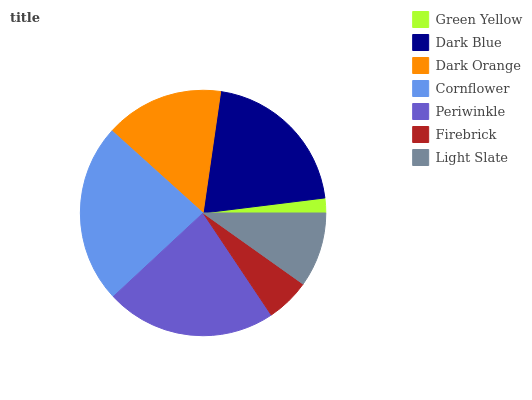Is Green Yellow the minimum?
Answer yes or no. Yes. Is Cornflower the maximum?
Answer yes or no. Yes. Is Dark Blue the minimum?
Answer yes or no. No. Is Dark Blue the maximum?
Answer yes or no. No. Is Dark Blue greater than Green Yellow?
Answer yes or no. Yes. Is Green Yellow less than Dark Blue?
Answer yes or no. Yes. Is Green Yellow greater than Dark Blue?
Answer yes or no. No. Is Dark Blue less than Green Yellow?
Answer yes or no. No. Is Dark Orange the high median?
Answer yes or no. Yes. Is Dark Orange the low median?
Answer yes or no. Yes. Is Cornflower the high median?
Answer yes or no. No. Is Firebrick the low median?
Answer yes or no. No. 